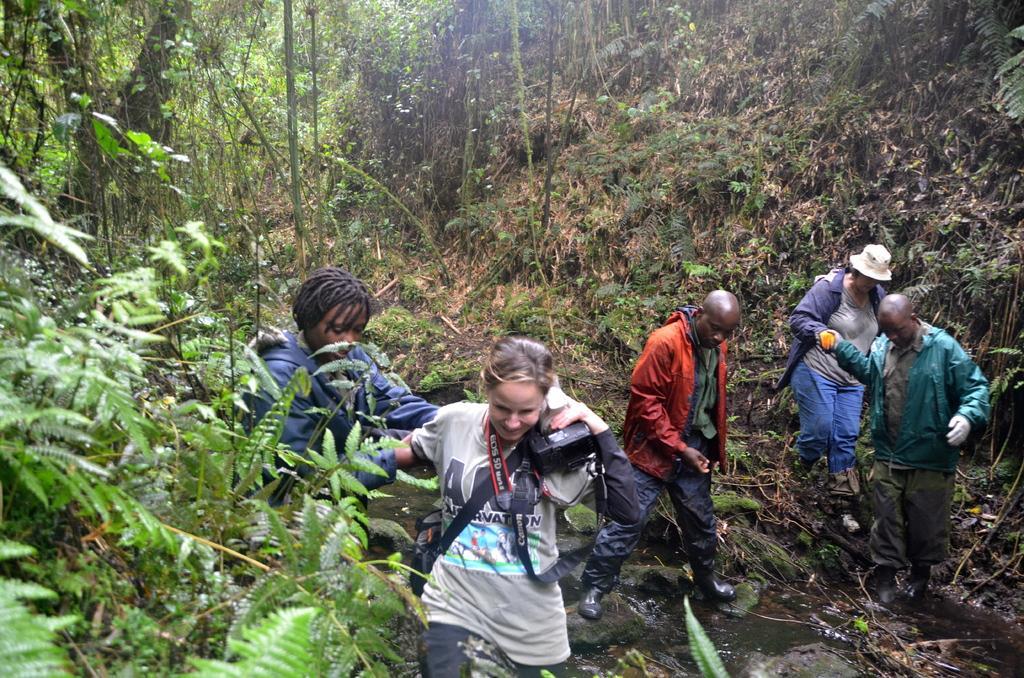Could you give a brief overview of what you see in this image? In the picture a group of people were walking in the forest and one of them is holding a camera, there are plenty of trees, plants and grass around the people. 